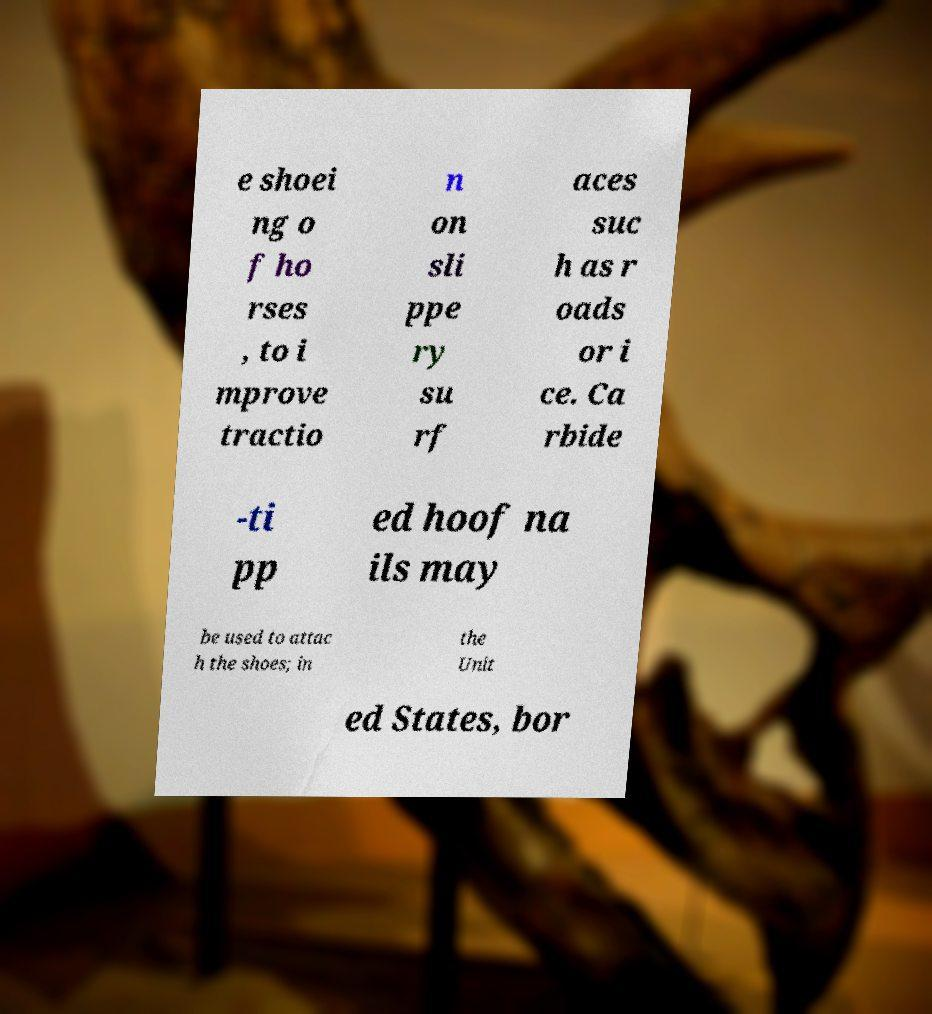There's text embedded in this image that I need extracted. Can you transcribe it verbatim? e shoei ng o f ho rses , to i mprove tractio n on sli ppe ry su rf aces suc h as r oads or i ce. Ca rbide -ti pp ed hoof na ils may be used to attac h the shoes; in the Unit ed States, bor 